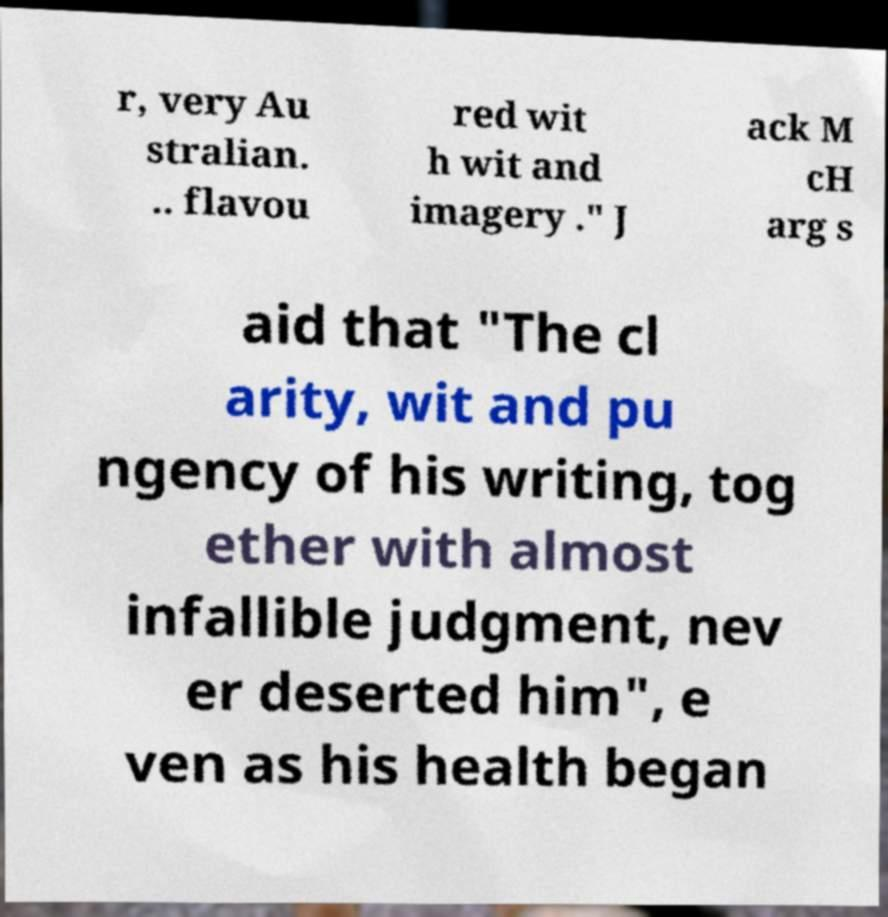For documentation purposes, I need the text within this image transcribed. Could you provide that? r, very Au stralian. .. flavou red wit h wit and imagery ." J ack M cH arg s aid that "The cl arity, wit and pu ngency of his writing, tog ether with almost infallible judgment, nev er deserted him", e ven as his health began 